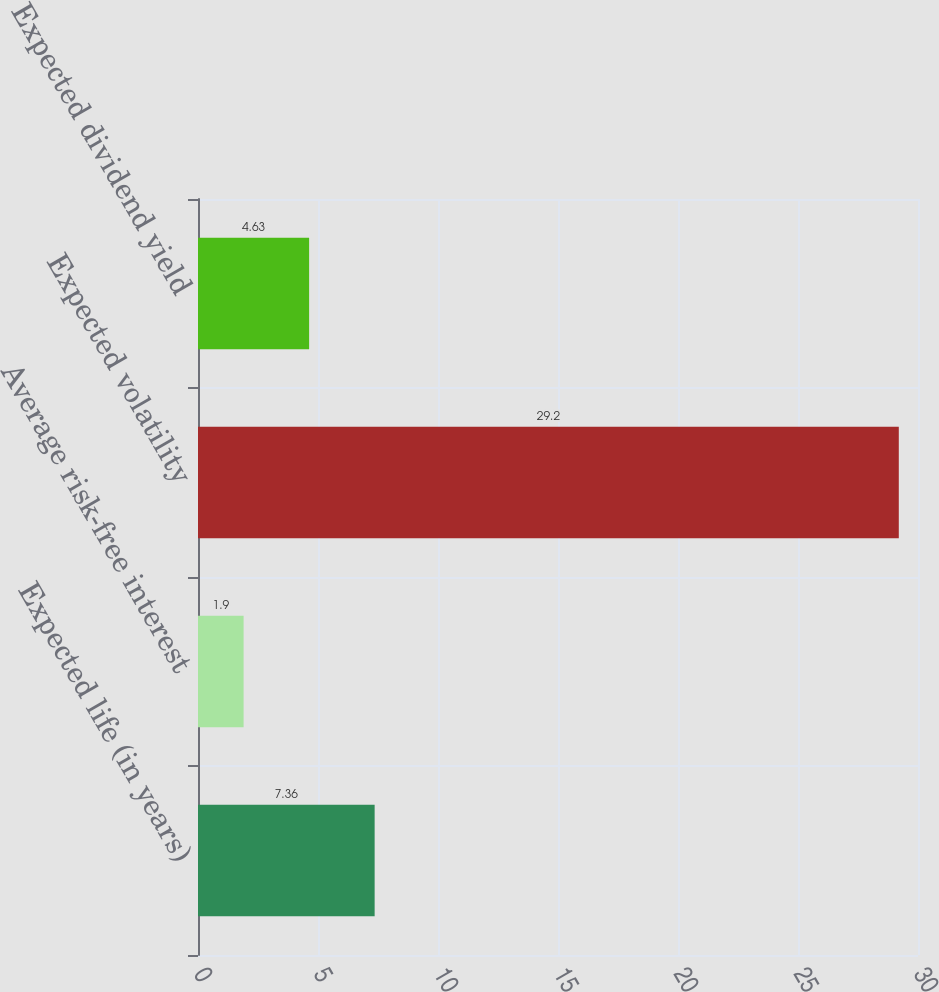<chart> <loc_0><loc_0><loc_500><loc_500><bar_chart><fcel>Expected life (in years)<fcel>Average risk-free interest<fcel>Expected volatility<fcel>Expected dividend yield<nl><fcel>7.36<fcel>1.9<fcel>29.2<fcel>4.63<nl></chart> 